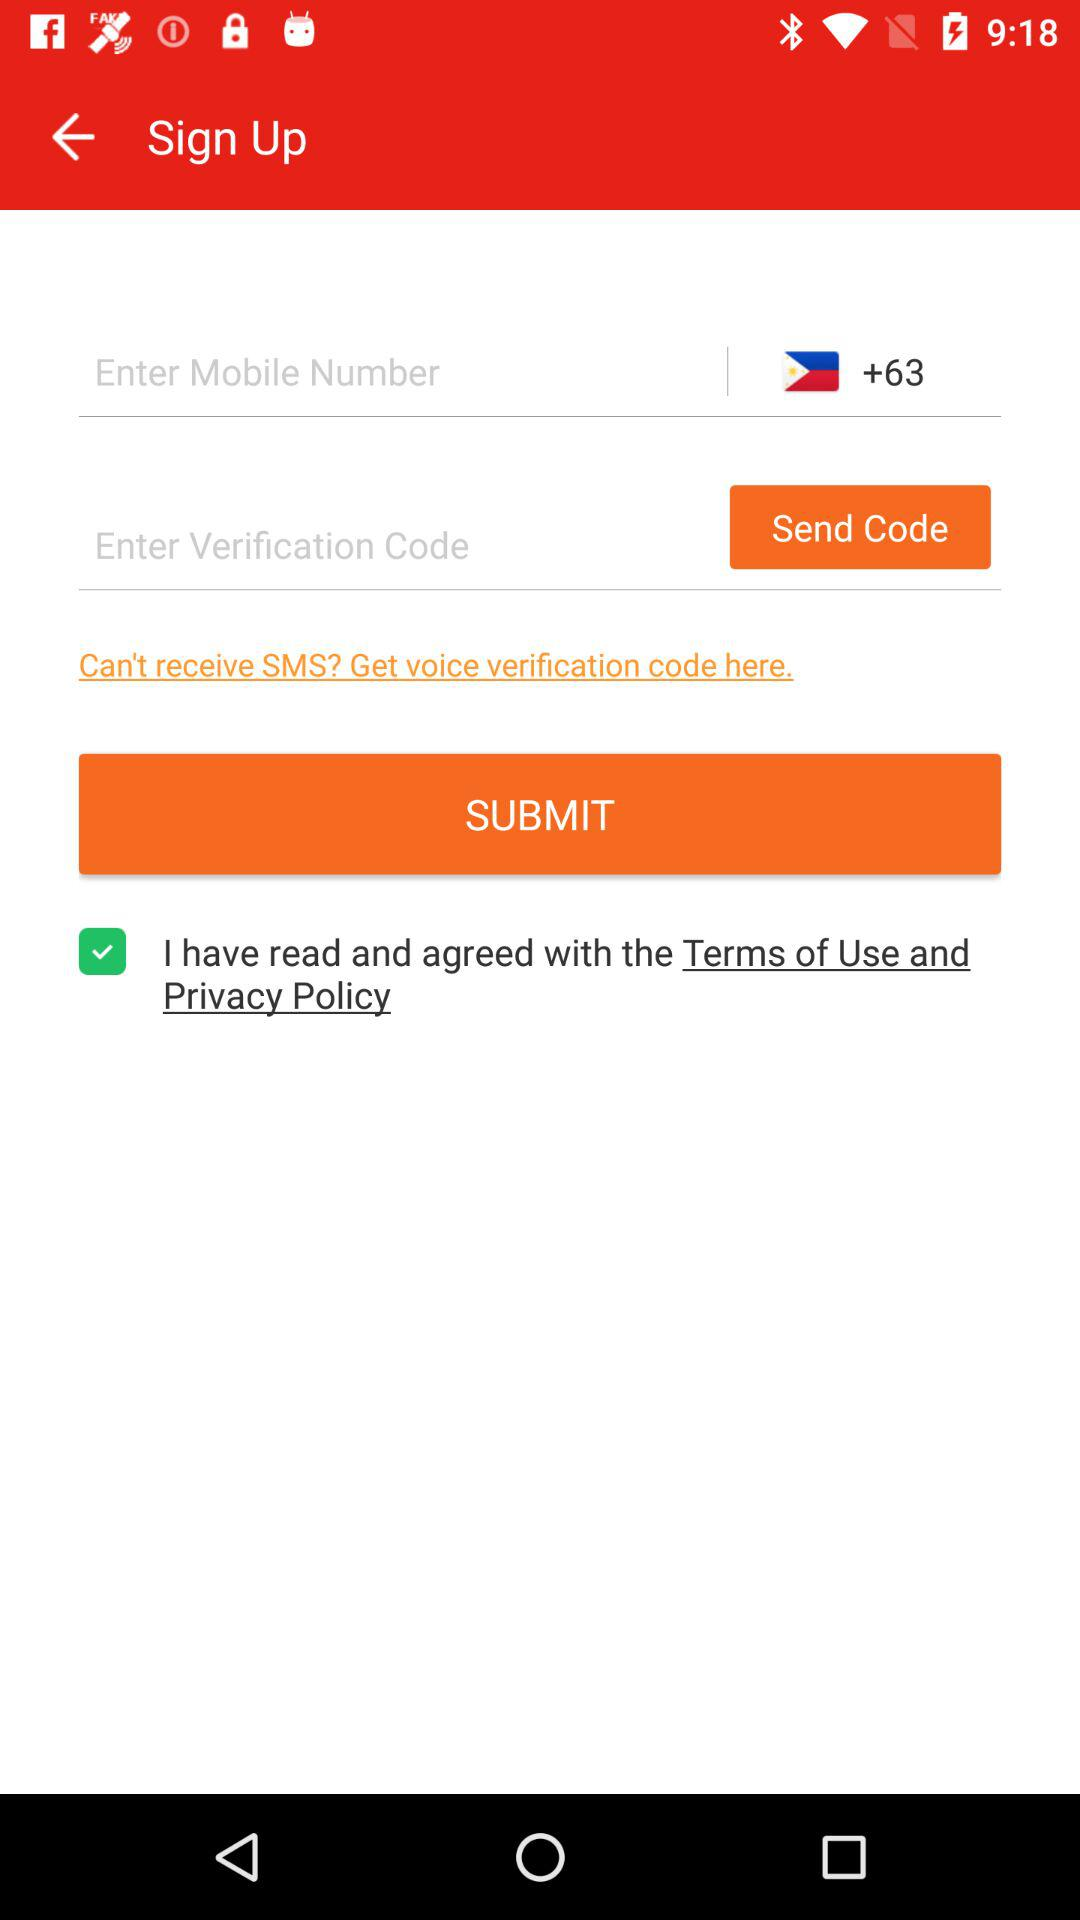What is the verification code?
When the provided information is insufficient, respond with <no answer>. <no answer> 